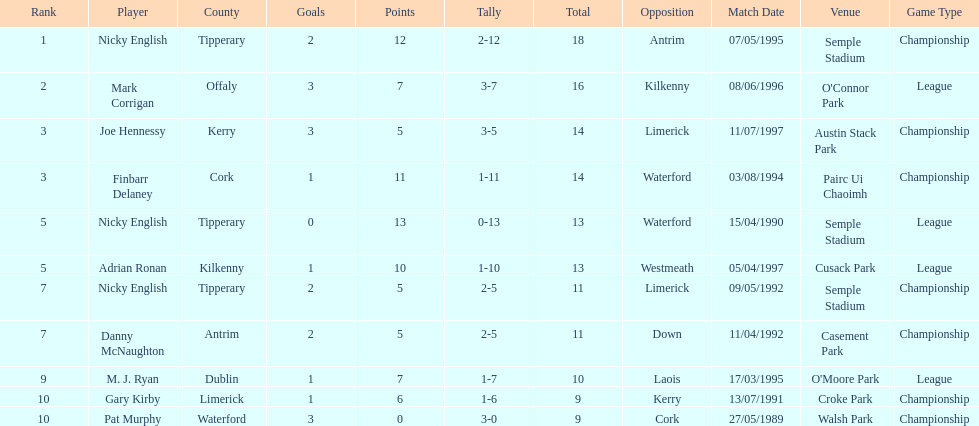How many people are on the list? 9. 